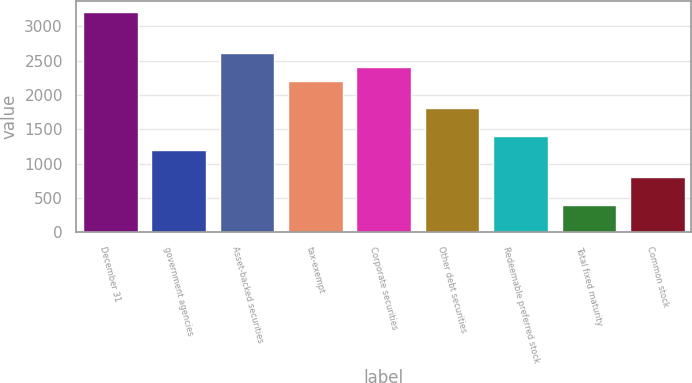Convert chart to OTSL. <chart><loc_0><loc_0><loc_500><loc_500><bar_chart><fcel>December 31<fcel>government agencies<fcel>Asset-backed securities<fcel>tax-exempt<fcel>Corporate securities<fcel>Other debt securities<fcel>Redeemable preferred stock<fcel>Total fixed maturity<fcel>Common stock<nl><fcel>3211.14<fcel>1204.24<fcel>2609.07<fcel>2207.69<fcel>2408.38<fcel>1806.31<fcel>1404.93<fcel>401.48<fcel>802.86<nl></chart> 